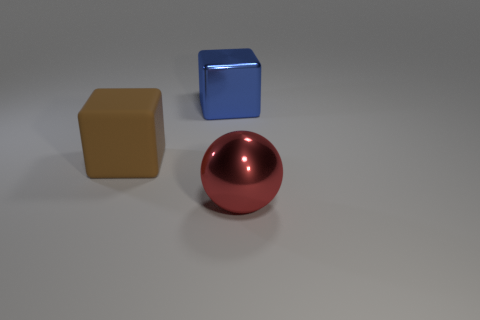Add 2 large blue metal objects. How many objects exist? 5 Subtract all balls. How many objects are left? 2 Add 3 tiny rubber balls. How many tiny rubber balls exist? 3 Subtract 0 blue spheres. How many objects are left? 3 Subtract all big things. Subtract all green rubber cubes. How many objects are left? 0 Add 2 big red things. How many big red things are left? 3 